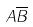<formula> <loc_0><loc_0><loc_500><loc_500>A \overline { B }</formula> 